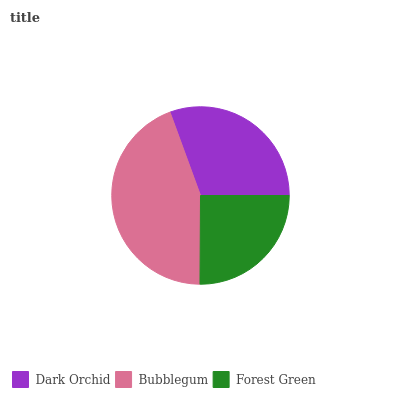Is Forest Green the minimum?
Answer yes or no. Yes. Is Bubblegum the maximum?
Answer yes or no. Yes. Is Bubblegum the minimum?
Answer yes or no. No. Is Forest Green the maximum?
Answer yes or no. No. Is Bubblegum greater than Forest Green?
Answer yes or no. Yes. Is Forest Green less than Bubblegum?
Answer yes or no. Yes. Is Forest Green greater than Bubblegum?
Answer yes or no. No. Is Bubblegum less than Forest Green?
Answer yes or no. No. Is Dark Orchid the high median?
Answer yes or no. Yes. Is Dark Orchid the low median?
Answer yes or no. Yes. Is Bubblegum the high median?
Answer yes or no. No. Is Bubblegum the low median?
Answer yes or no. No. 